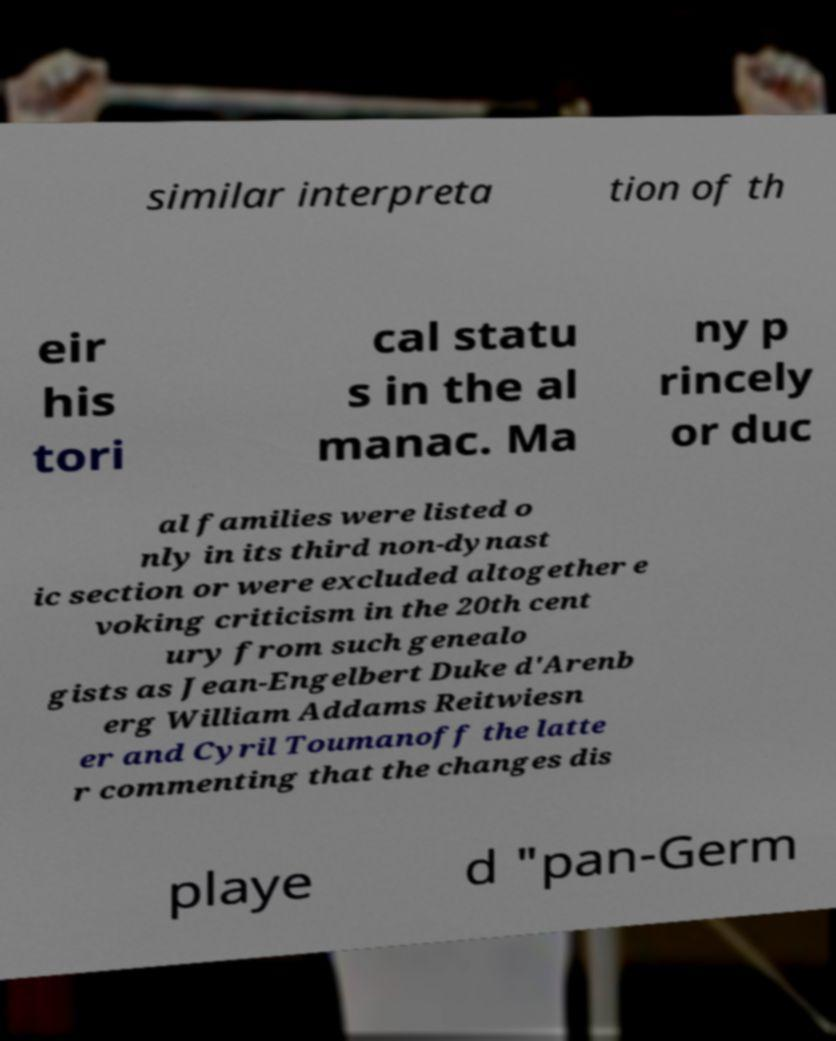What messages or text are displayed in this image? I need them in a readable, typed format. similar interpreta tion of th eir his tori cal statu s in the al manac. Ma ny p rincely or duc al families were listed o nly in its third non-dynast ic section or were excluded altogether e voking criticism in the 20th cent ury from such genealo gists as Jean-Engelbert Duke d'Arenb erg William Addams Reitwiesn er and Cyril Toumanoff the latte r commenting that the changes dis playe d "pan-Germ 